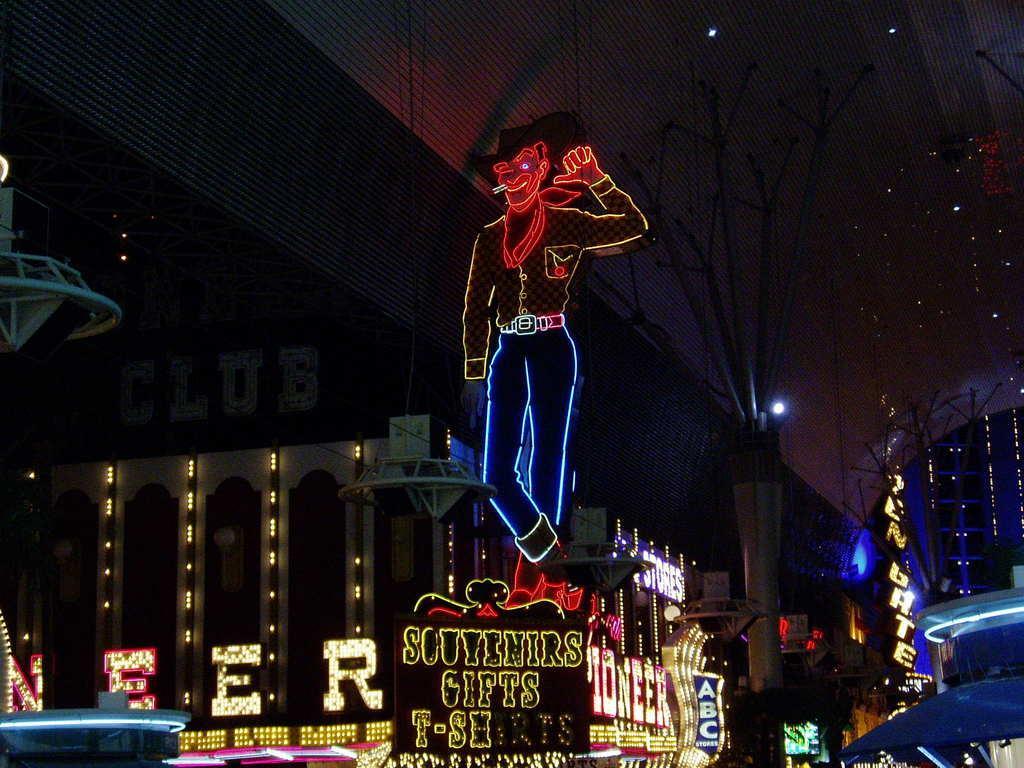Describe this image in one or two sentences. In this picture I can see the decorative lights. I can see the buildings. I can see lcd screens. I can see hoardings. 